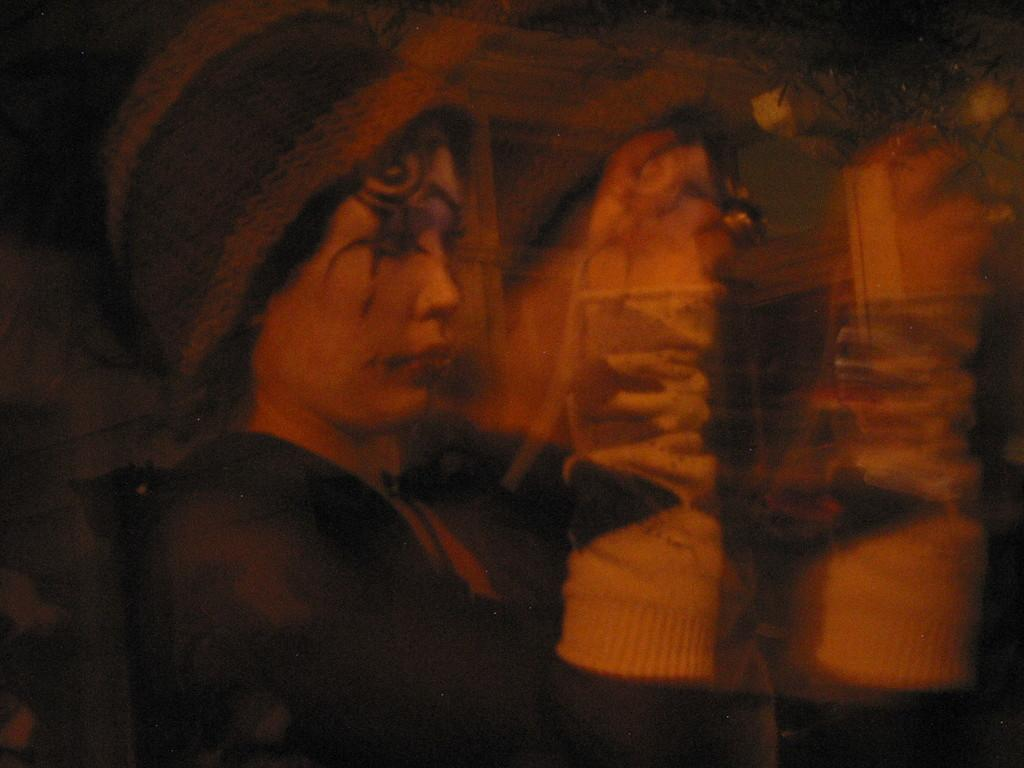What type of image is being described? The image is an edited picture. Can you describe the person in the image? There is a person in the image, and they are wearing gloves and have a tattoo on their face. What is the person holding in the image? The person is holding a device in the image. Reasoning: Let's think step by step by step in order to produce the conversation. We start by identifying the nature of the image, which is an edited picture. Then, we focus on the person in the image, describing their appearance and what they are holding. Each question is designed to elicit a specific detail about the image that is known from the provided facts. Absurd Question/Answer: What type of shop can be seen in the background of the image? There is no shop visible in the image; it only features a person wearing gloves, holding a device, and having a tattoo on their face. Can you describe how the snail is being pulled in the image? There is no snail present in the image, so it cannot be pulled or described. 